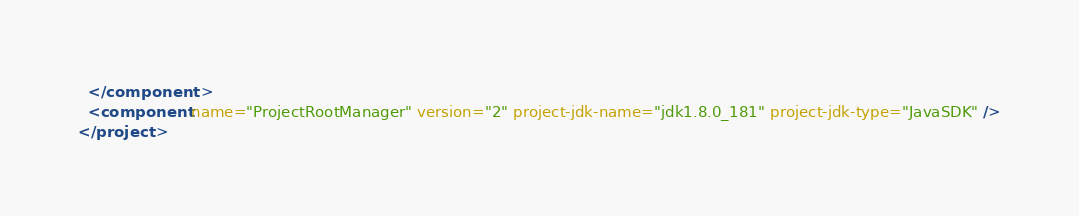Convert code to text. <code><loc_0><loc_0><loc_500><loc_500><_XML_>  </component>
  <component name="ProjectRootManager" version="2" project-jdk-name="jdk1.8.0_181" project-jdk-type="JavaSDK" />
</project></code> 